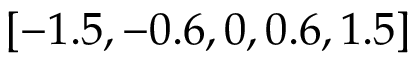Convert formula to latex. <formula><loc_0><loc_0><loc_500><loc_500>\left [ - 1 . 5 , - 0 . 6 , 0 , 0 . 6 , 1 . 5 \right ]</formula> 